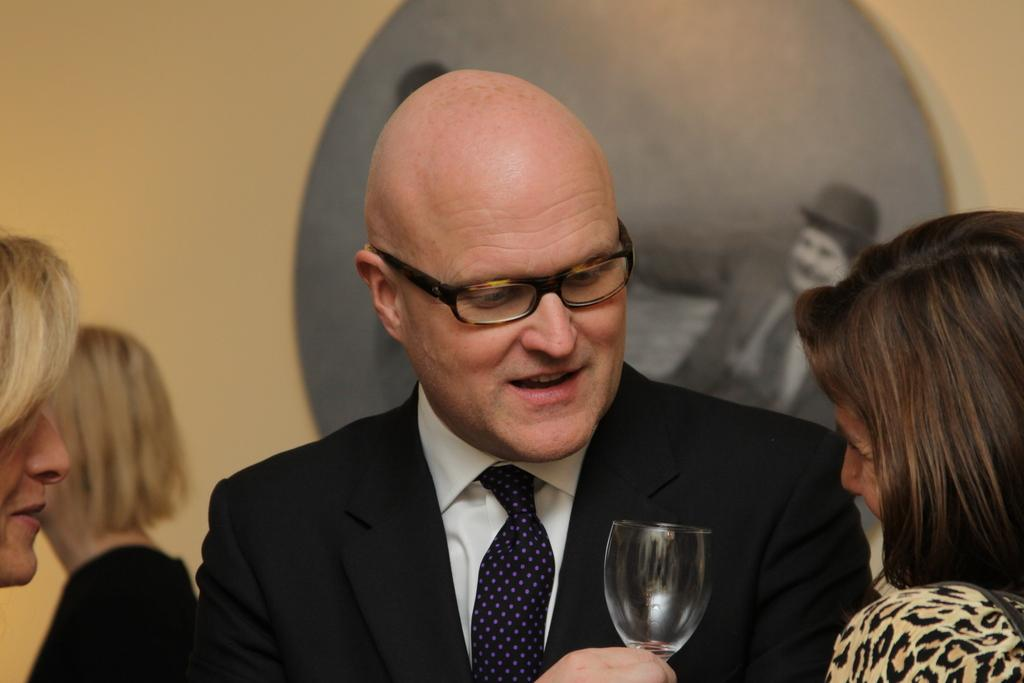How many people are present in the image? There are four people in the image. Can you describe what one of the people is doing? Yes, a man is holding a glass in the image. What type of wood can be seen in the advertisement in the image? There is no advertisement or wood present in the image; it only features four people, one of whom is holding a glass. 